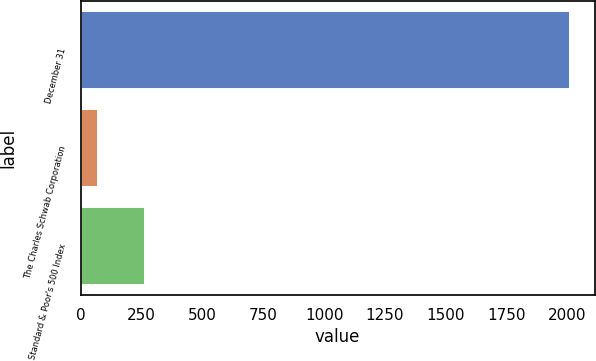<chart> <loc_0><loc_0><loc_500><loc_500><bar_chart><fcel>December 31<fcel>The Charles Schwab Corporation<fcel>Standard & Poor's 500 Index<nl><fcel>2010<fcel>70<fcel>264<nl></chart> 